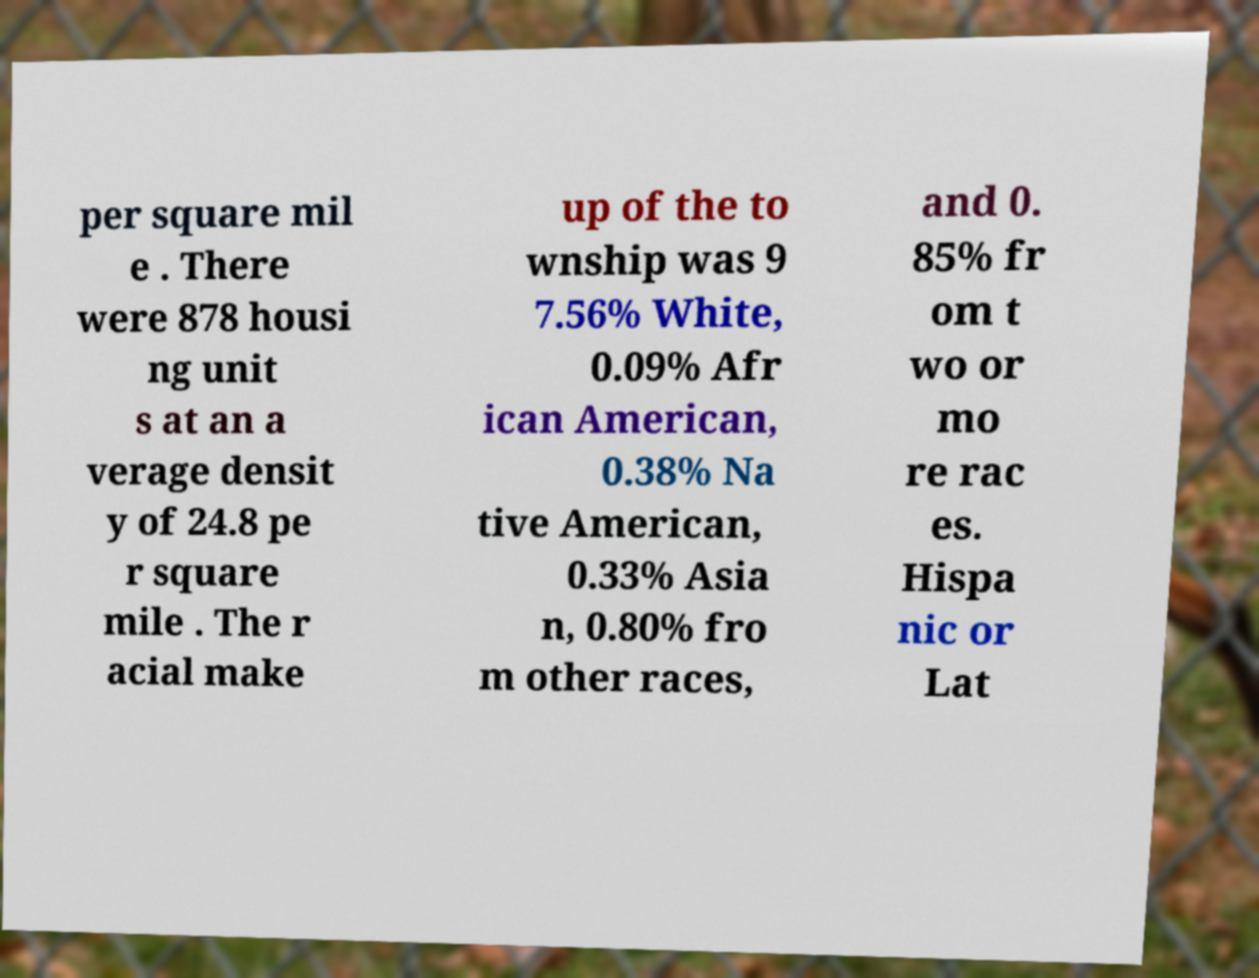Please identify and transcribe the text found in this image. per square mil e . There were 878 housi ng unit s at an a verage densit y of 24.8 pe r square mile . The r acial make up of the to wnship was 9 7.56% White, 0.09% Afr ican American, 0.38% Na tive American, 0.33% Asia n, 0.80% fro m other races, and 0. 85% fr om t wo or mo re rac es. Hispa nic or Lat 